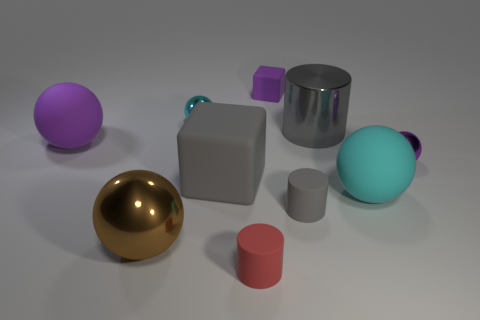Describe the composition of the objects in terms of materials or textures that are noticeable. From the visual textures displayed in the image, the objects seem to be made of different materials. The golden sphere and the shiny silver cylinder have reflective surfaces, suggesting they could be metallic. The purple and lavender cubes along with the pinkish short cylinder show a matte finish, perhaps indicative of a plastic or painted wood. The grayish cube and the smaller gray cylinder exhibit a slightly rough texture, potentially indicative of stone or concrete, while the cyan ovoid object has a smoother, almost glass-like appearance. 